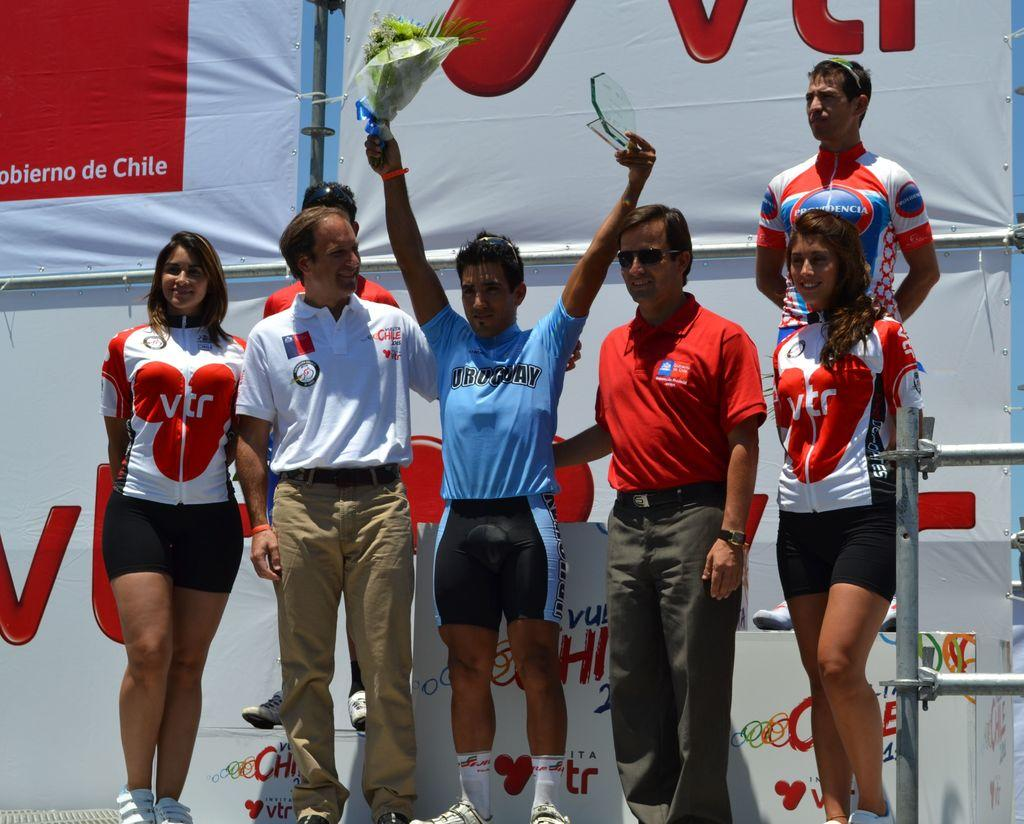<image>
Render a clear and concise summary of the photo. a girl with VTR on her shirt with other people 